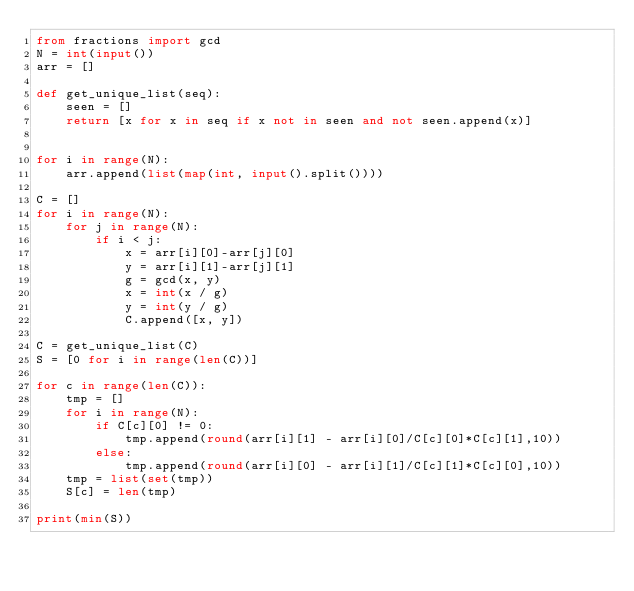Convert code to text. <code><loc_0><loc_0><loc_500><loc_500><_Python_>from fractions import gcd
N = int(input())
arr = []

def get_unique_list(seq):
    seen = []
    return [x for x in seq if x not in seen and not seen.append(x)]


for i in range(N):
    arr.append(list(map(int, input().split())))

C = []
for i in range(N):
    for j in range(N):
        if i < j:
            x = arr[i][0]-arr[j][0]
            y = arr[i][1]-arr[j][1]
            g = gcd(x, y)
            x = int(x / g)
            y = int(y / g)
            C.append([x, y])

C = get_unique_list(C)
S = [0 for i in range(len(C))]

for c in range(len(C)):
    tmp = []
    for i in range(N):
        if C[c][0] != 0:
            tmp.append(round(arr[i][1] - arr[i][0]/C[c][0]*C[c][1],10))
        else:
            tmp.append(round(arr[i][0] - arr[i][1]/C[c][1]*C[c][0],10))
    tmp = list(set(tmp))
    S[c] = len(tmp)

print(min(S))
</code> 